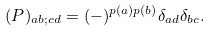<formula> <loc_0><loc_0><loc_500><loc_500>( P ) _ { a b ; c d } = ( - ) ^ { p ( a ) p ( b ) } \delta _ { a d } \delta _ { b c } .</formula> 